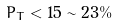Convert formula to latex. <formula><loc_0><loc_0><loc_500><loc_500>\bar { P } _ { T } < 1 5 \sim 2 3 \%</formula> 